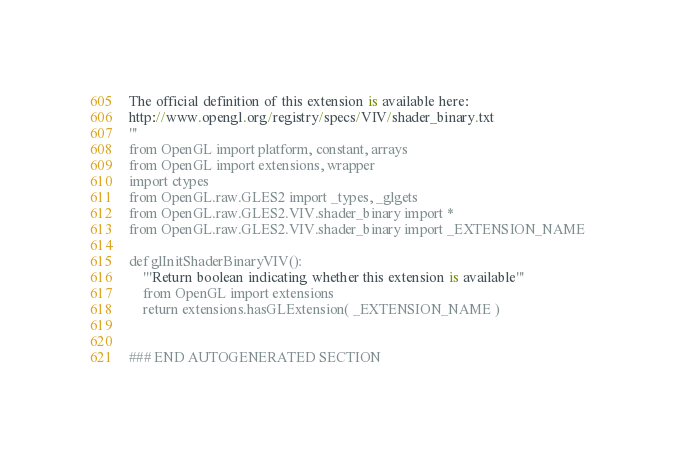<code> <loc_0><loc_0><loc_500><loc_500><_Python_>
The official definition of this extension is available here:
http://www.opengl.org/registry/specs/VIV/shader_binary.txt
'''
from OpenGL import platform, constant, arrays
from OpenGL import extensions, wrapper
import ctypes
from OpenGL.raw.GLES2 import _types, _glgets
from OpenGL.raw.GLES2.VIV.shader_binary import *
from OpenGL.raw.GLES2.VIV.shader_binary import _EXTENSION_NAME

def glInitShaderBinaryVIV():
    '''Return boolean indicating whether this extension is available'''
    from OpenGL import extensions
    return extensions.hasGLExtension( _EXTENSION_NAME )


### END AUTOGENERATED SECTION</code> 